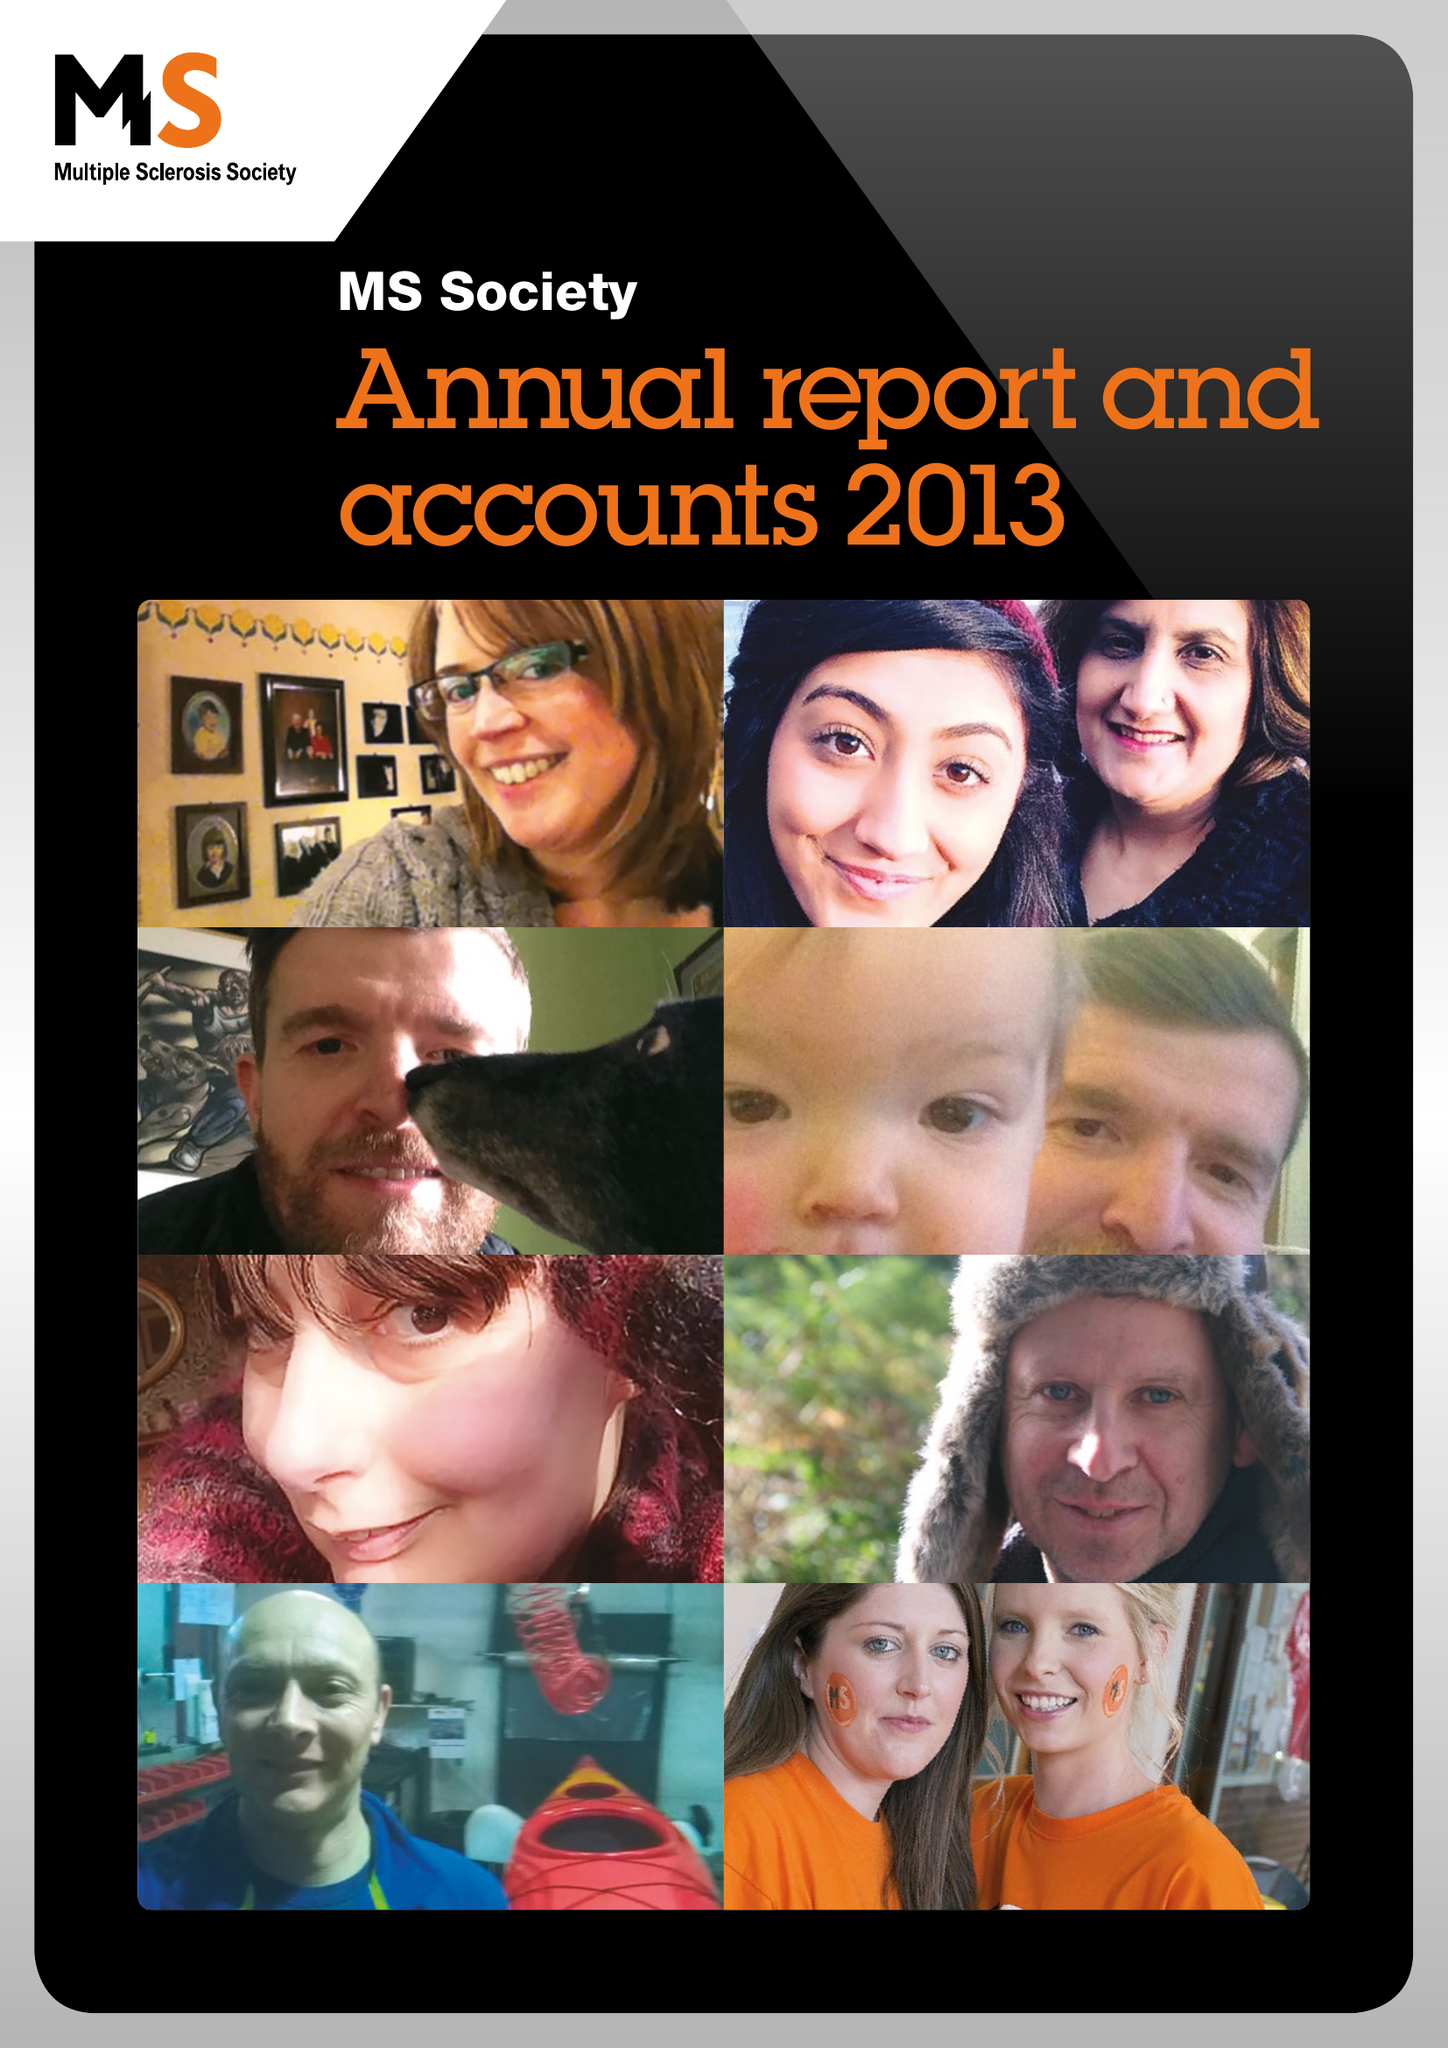What is the value for the income_annually_in_british_pounds?
Answer the question using a single word or phrase. 24093000.00 